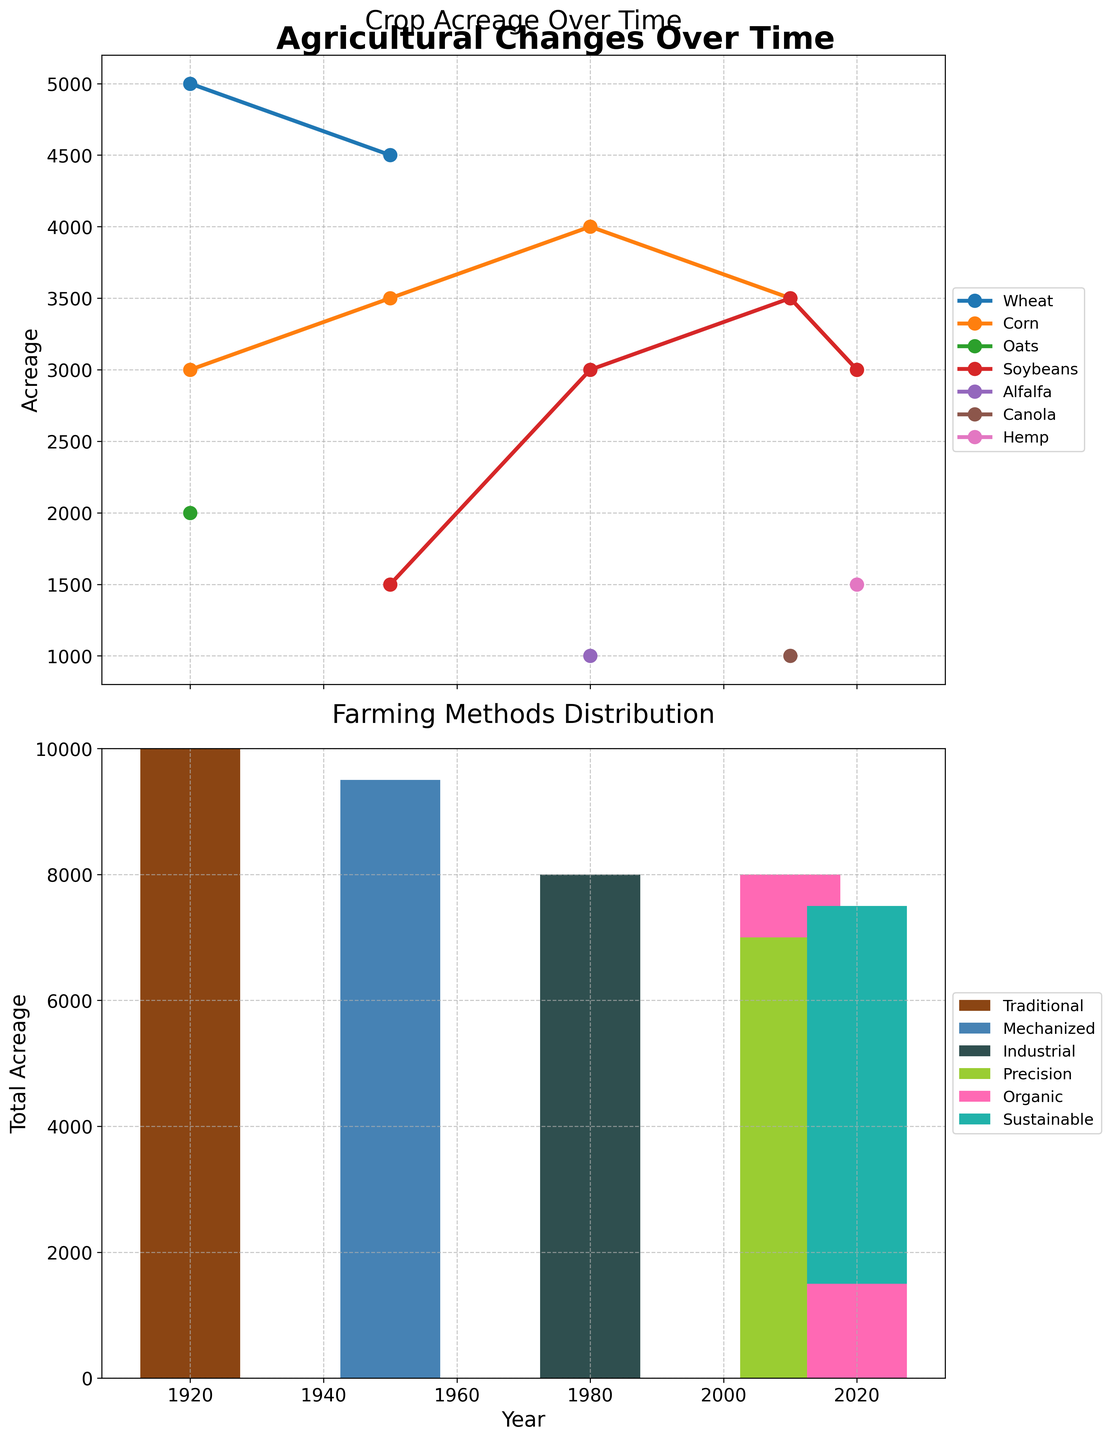Which crop had the highest acreage in 1920? In the first plot, look at the data points for the year 1920 and identify the crop with the highest acreage. Wheat, Corn, and Oats are the crops shown, and Wheat has the highest acreage at 5000.
Answer: Wheat What is the total acreage for Soybeans across all years? Observe the data points in the first plot for Soybeans. Sum the acreages listed for Soybeans in all the years depicted (1950, 1980, 2010, 2020). The values are 1500, 3000, 3500, and 3000, respectively. Add these numbers together: 1500 + 3000 + 3500 + 3000.
Answer: 11000 How did the total acreage change from 1920 to 1950? Refer to the first plot and sum the acreages for all crops in 1920 and in 1950. For 1920: Wheat (5000) + Corn (3000) + Oats (2000) = 10000. For 1950: Wheat (4500) + Corn (3500) + Soybeans (1500) = 9500. Calculate the difference: 10000 - 9500.
Answer: Decreased by 500 Which farming method had the largest total acreage in 2020? Look at the second plot's bars for 2020 and analyze their heights. Identify the farming method with the tallest bar segment, which represents the largest total acreage. Sustainable (6000) and Organic (1500) segments are visible, and Sustainable is taller.
Answer: Sustainable What is the trend in Corn acreage from 1980 to 2020? Observe the Corn data points in the first plot for the years 1980, 2010, and 2020. The acreages are: 4000 in 1980, 3500 in 2010, and 3000 in 2020. Analyze the sequence to determine the trend: 4000 → 3500 → 3000, showing a consistent decline.
Answer: Declining Are there any years where more than one crop has the exact same acreage? Compare the data points visually for each year in the first plot. In 2010, both Corn and Soybeans have 3500 acres, showing an overlap.
Answer: Yes What is the most frequently used farming method across all recorded years? Refer to the second subplot and count each farming method's bar segments across all years. Mechanized, Industrial, and Precision methods each appear 2 times, but Mechanized and Industrial share a higher total contribution visually. Precision and Sustainable methods each appear only once. Mechanized and Industrial are used equally frequently.
Answer: Mechanized and Industrial By how much did the acreage of Wheat change from 1920 to 1950? In the first plot, note the acreages of Wheat in 1920 and 1950. For 1920, Wheat has 5000 acres, and in 1950, it has 4500 acres. Subtract 4500 from 5000 to find the difference.
Answer: Decreased by 500 How does the distribution of farming methods change over time according to the lower subplot? Look at the second subplot and observe the variation in the heights of the bars for each farming method across different years. You will notice transitions from Traditional in 1920, Mechanized in 1950, Industrial in 1980, Precision in 2010, and both Sustainable and Organic in 2020, indicating noticeable shifts in favored methods over time.
Answer: Varied transitions reflecting technological advancements 